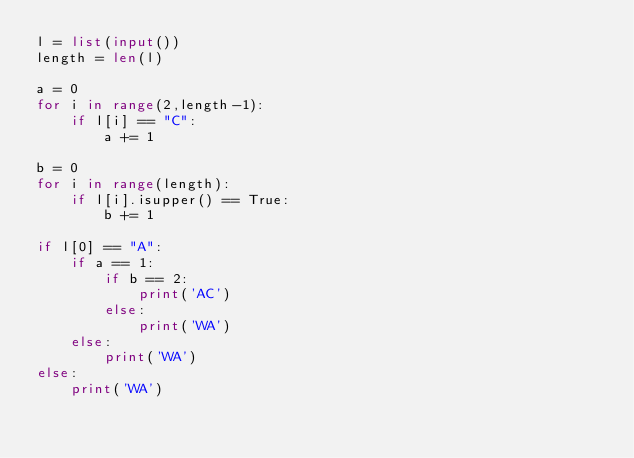Convert code to text. <code><loc_0><loc_0><loc_500><loc_500><_Python_>l = list(input())
length = len(l)

a = 0
for i in range(2,length-1):
    if l[i] == "C":
        a += 1
        
b = 0
for i in range(length):
    if l[i].isupper() == True:
        b += 1

if l[0] == "A":
    if a == 1:
        if b == 2:
            print('AC')
        else:
            print('WA')
    else:
        print('WA')
else:
    print('WA')</code> 